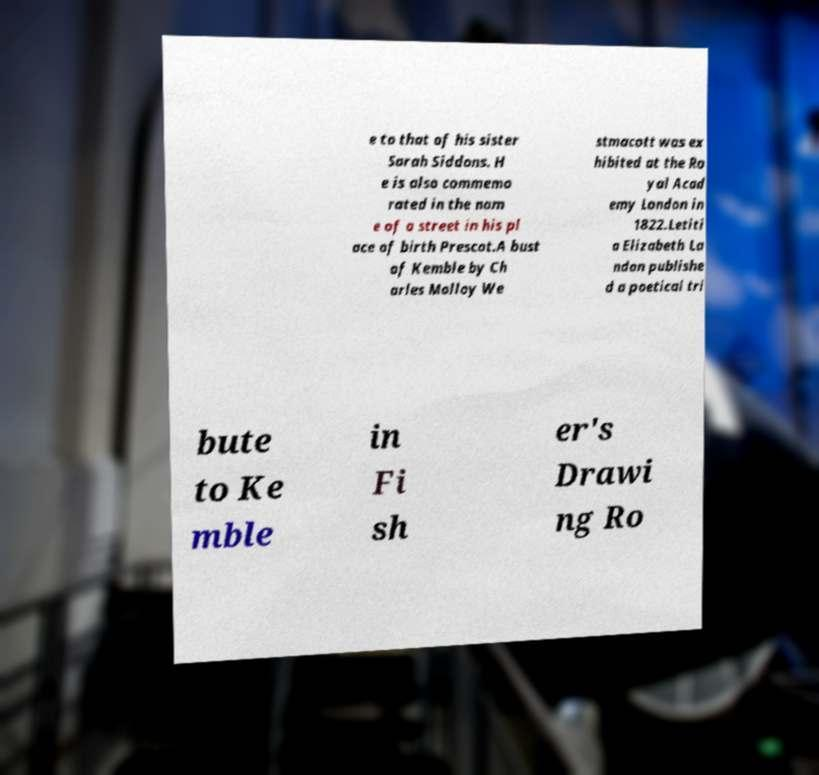Please identify and transcribe the text found in this image. e to that of his sister Sarah Siddons. H e is also commemo rated in the nam e of a street in his pl ace of birth Prescot.A bust of Kemble by Ch arles Molloy We stmacott was ex hibited at the Ro yal Acad emy London in 1822.Letiti a Elizabeth La ndon publishe d a poetical tri bute to Ke mble in Fi sh er's Drawi ng Ro 